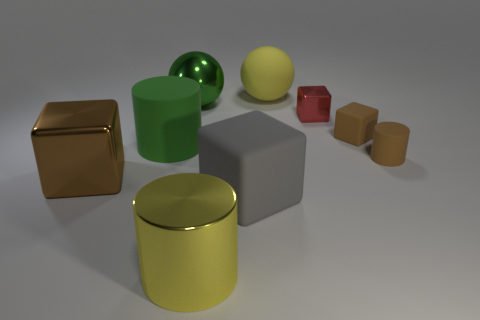Are there more cubes than purple objects?
Make the answer very short. Yes. There is a metal cylinder that is the same color as the big rubber ball; what is its size?
Provide a short and direct response. Large. There is a cube that is both right of the big yellow sphere and on the left side of the small brown block; how big is it?
Give a very brief answer. Small. There is a brown object that is to the right of the brown block that is to the right of the rubber cylinder that is to the left of the brown matte cylinder; what is its material?
Ensure brevity in your answer.  Rubber. What material is the large object that is the same color as the large matte sphere?
Your answer should be very brief. Metal. Does the rubber cylinder to the right of the gray thing have the same color as the big metal thing behind the tiny red shiny object?
Give a very brief answer. No. What is the shape of the rubber object that is on the left side of the ball in front of the yellow object right of the large metallic cylinder?
Make the answer very short. Cylinder. The brown thing that is both to the right of the large green metallic sphere and left of the tiny cylinder has what shape?
Offer a terse response. Cube. What number of large metallic spheres are in front of the cube that is on the left side of the matte cube that is to the left of the large yellow rubber object?
Keep it short and to the point. 0. What is the size of the brown metallic thing that is the same shape as the red object?
Your answer should be compact. Large. 